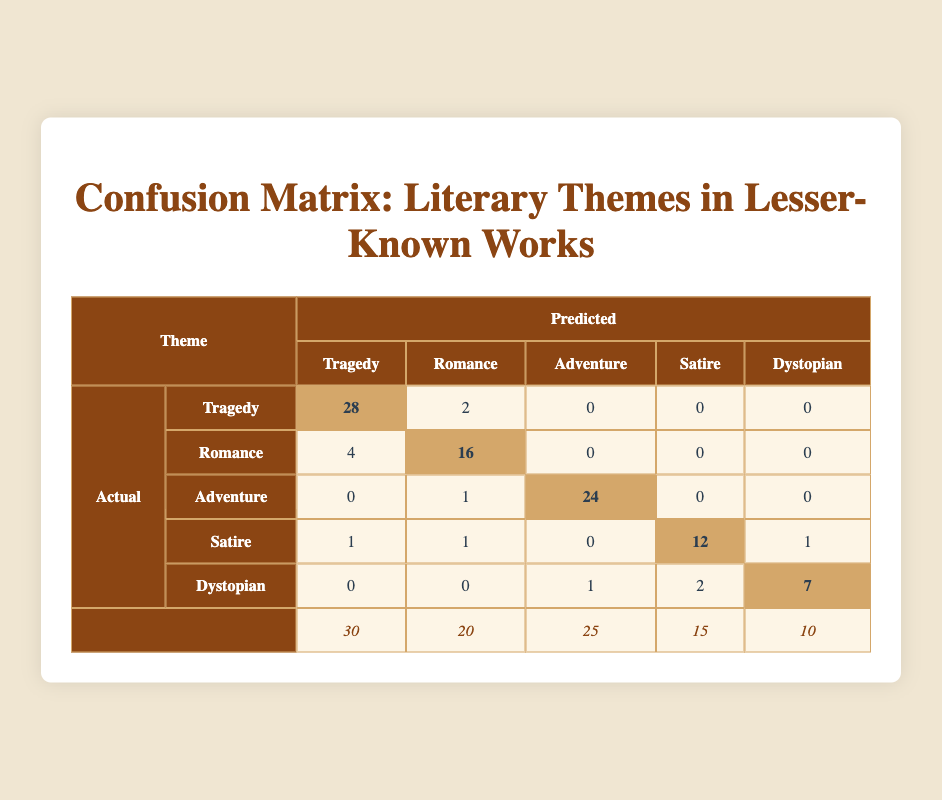What is the predicted number of Romance themes that are correctly classified as Romance? In the table, the value under the Romance row and Romance column indicates the correctly classified Romance themes, which is 16.
Answer: 16 How many Tragedy themes were misclassified as Romance? The value in the Tragedy row and Romance column indicates how many Tragedy themes were misclassified. This value is 4.
Answer: 4 What is the total number of Adventure themes according to the actual counts? The actual total for Adventure themes is listed in the last row under the Adventure column, which is 25.
Answer: 25 Are more Dystopian themes misclassified as Satire compared to the Tragedy themes misclassified as Satire? For Dystopian themes misclassified as Satire, the value is 2, and for Tragedy themes misclassified as Satire, the value is 0. Since 2 (Dystopian) is greater than 0 (Tragedy), the answer is yes.
Answer: Yes What is the average count of themes predicted correctly across all categories? To find the average, sum the diagonal values: (28 + 16 + 24 + 12 + 7) = 87; then divide by the number of themes (5), which gives 87/5 = 17.4.
Answer: 17.4 How many Adventure themes were predicted as a different genre apart from Adventure itself? The total Adventure themes predicted differently is the sum of misclassifications: 0 (Tragedy) + 1 (Romance) + 0 (Satire) + 0 (Dystopian) = 1.
Answer: 1 What percentage of actual Tragedy themes were correctly classified? The correctly classified Tragedy themes are 28 out of a total of 30, which gives (28/30) * 100 = 93.33%.
Answer: 93.33% How many total misclassifications occurred across all themes? To find the misclassifications, calculate the sum of the misclassified values: 4 (Romance) + 2 (Romance) + 1 (Satire) + 1 (Satire) + 0 (Dystopian) + 0 (Dystopian) + 0 (Tragedy) + 1 (Adventure) = 11.
Answer: 11 What is the difference between the number of correctly classified Satire themes and Dystopian themes? For Satire, the correctly classified count is 12, and for Dystopian, it is 7. The difference is 12 - 7 = 5.
Answer: 5 